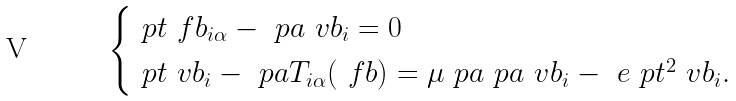Convert formula to latex. <formula><loc_0><loc_0><loc_500><loc_500>\begin{cases} \ p t \ f b _ { i \alpha } - \ p a \ v b _ { i } = 0 & \\ \ p t \ v b _ { i } - \ p a T _ { i \alpha } ( \ f b ) = \mu \ p a \ p a \ v b _ { i } - \ e \ p t ^ { 2 } \ v b _ { i } . & \\ \end{cases}</formula> 